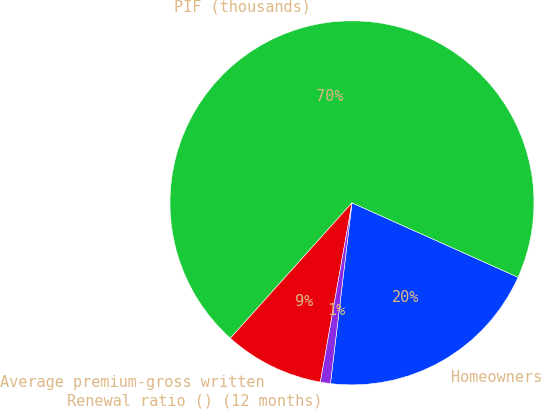Convert chart. <chart><loc_0><loc_0><loc_500><loc_500><pie_chart><fcel>Homeowners<fcel>PIF (thousands)<fcel>Average premium-gross written<fcel>Renewal ratio () (12 months)<nl><fcel>20.18%<fcel>70.06%<fcel>8.87%<fcel>0.89%<nl></chart> 